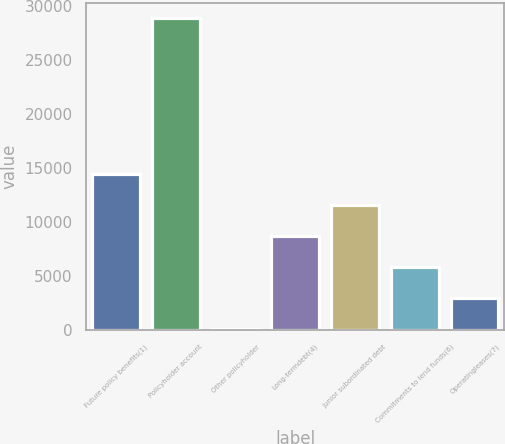Convert chart. <chart><loc_0><loc_0><loc_500><loc_500><bar_chart><fcel>Future policy benefits(1)<fcel>Policyholder account<fcel>Other policyholder<fcel>Long-termdebt(4)<fcel>Junior subordinated debt<fcel>Commitments to lend funds(6)<fcel>Operatingleases(7)<nl><fcel>14489<fcel>28884<fcel>94<fcel>8731<fcel>11610<fcel>5852<fcel>2973<nl></chart> 